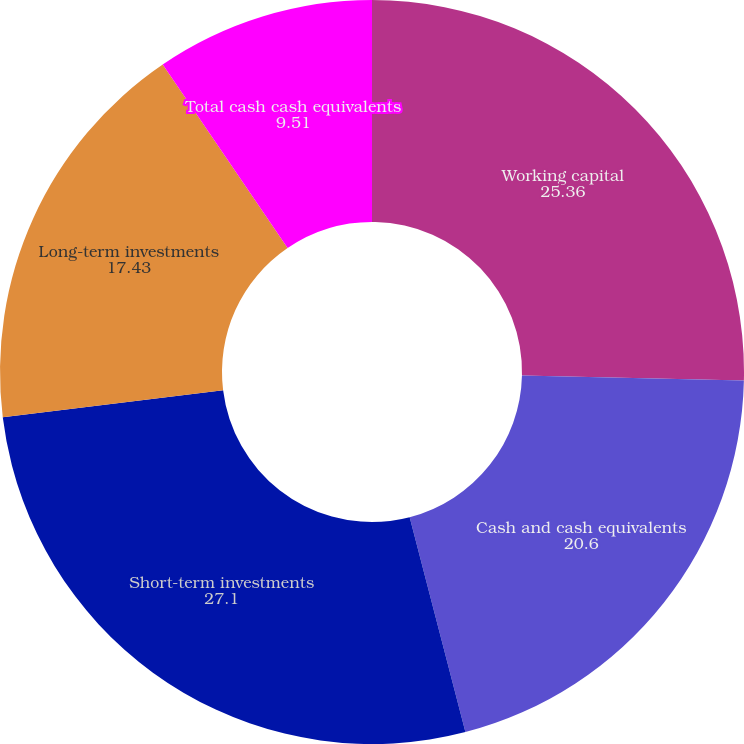Convert chart to OTSL. <chart><loc_0><loc_0><loc_500><loc_500><pie_chart><fcel>Working capital<fcel>Cash and cash equivalents<fcel>Short-term investments<fcel>Long-term investments<fcel>Total cash cash equivalents<nl><fcel>25.36%<fcel>20.6%<fcel>27.1%<fcel>17.43%<fcel>9.51%<nl></chart> 